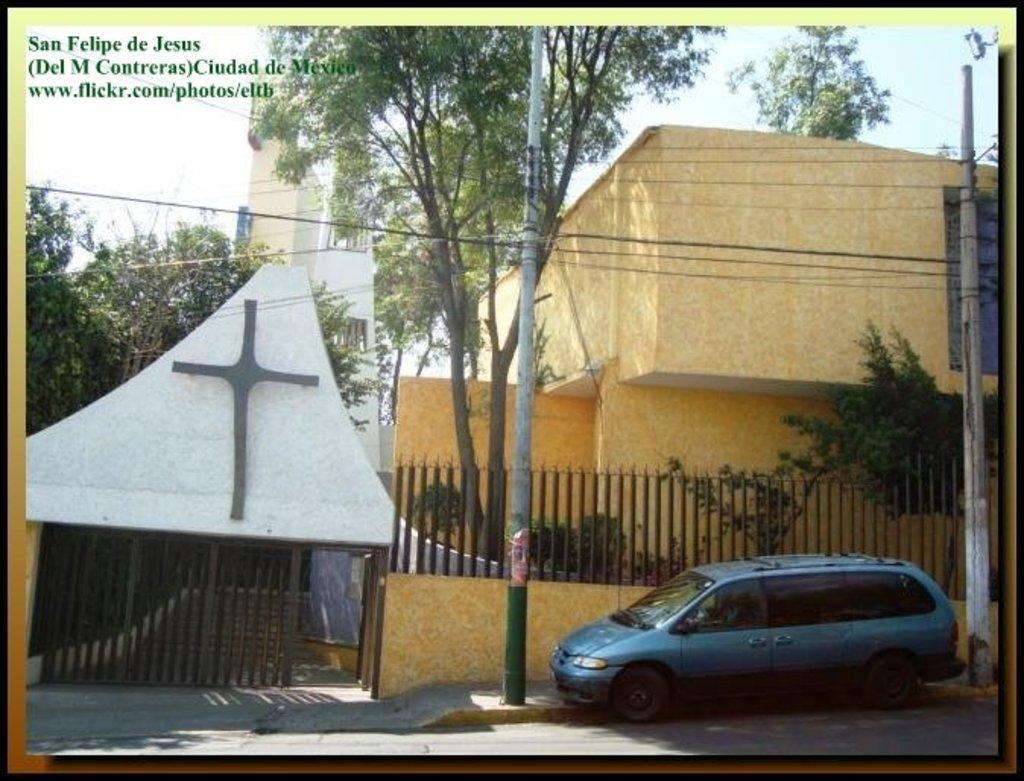Could you give a brief overview of what you see in this image? In this image I can see a photograph in which I can see the road, a car, few metal poles, few wires to the poles, few trees, the gate , the railing and few buildings. In the background I can see the sky. 